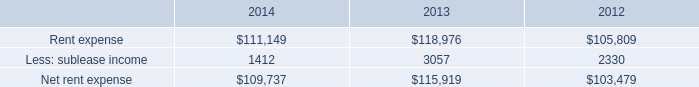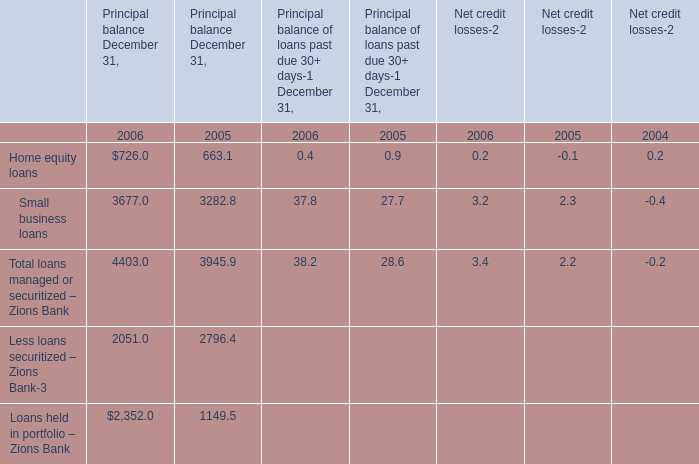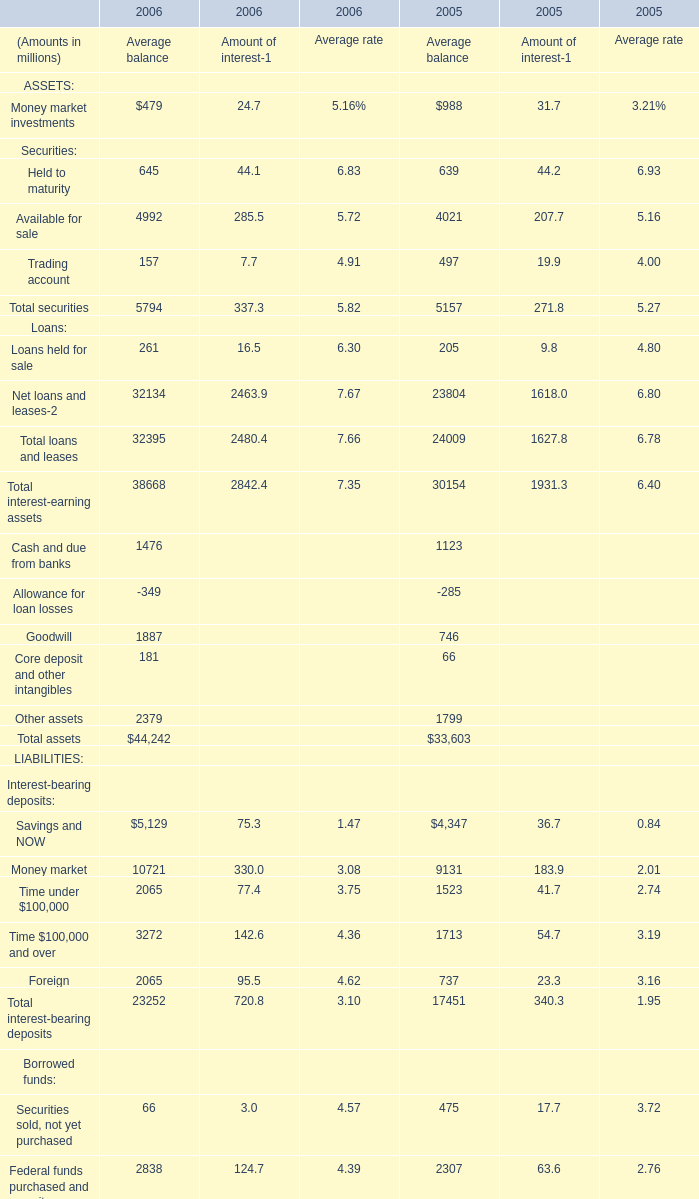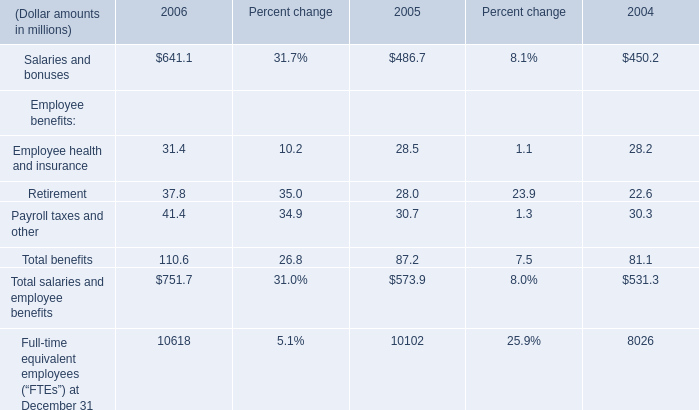How long does Available for sale for Average balance keep growing? 
Computations: (2006 - 2005)
Answer: 1.0. 